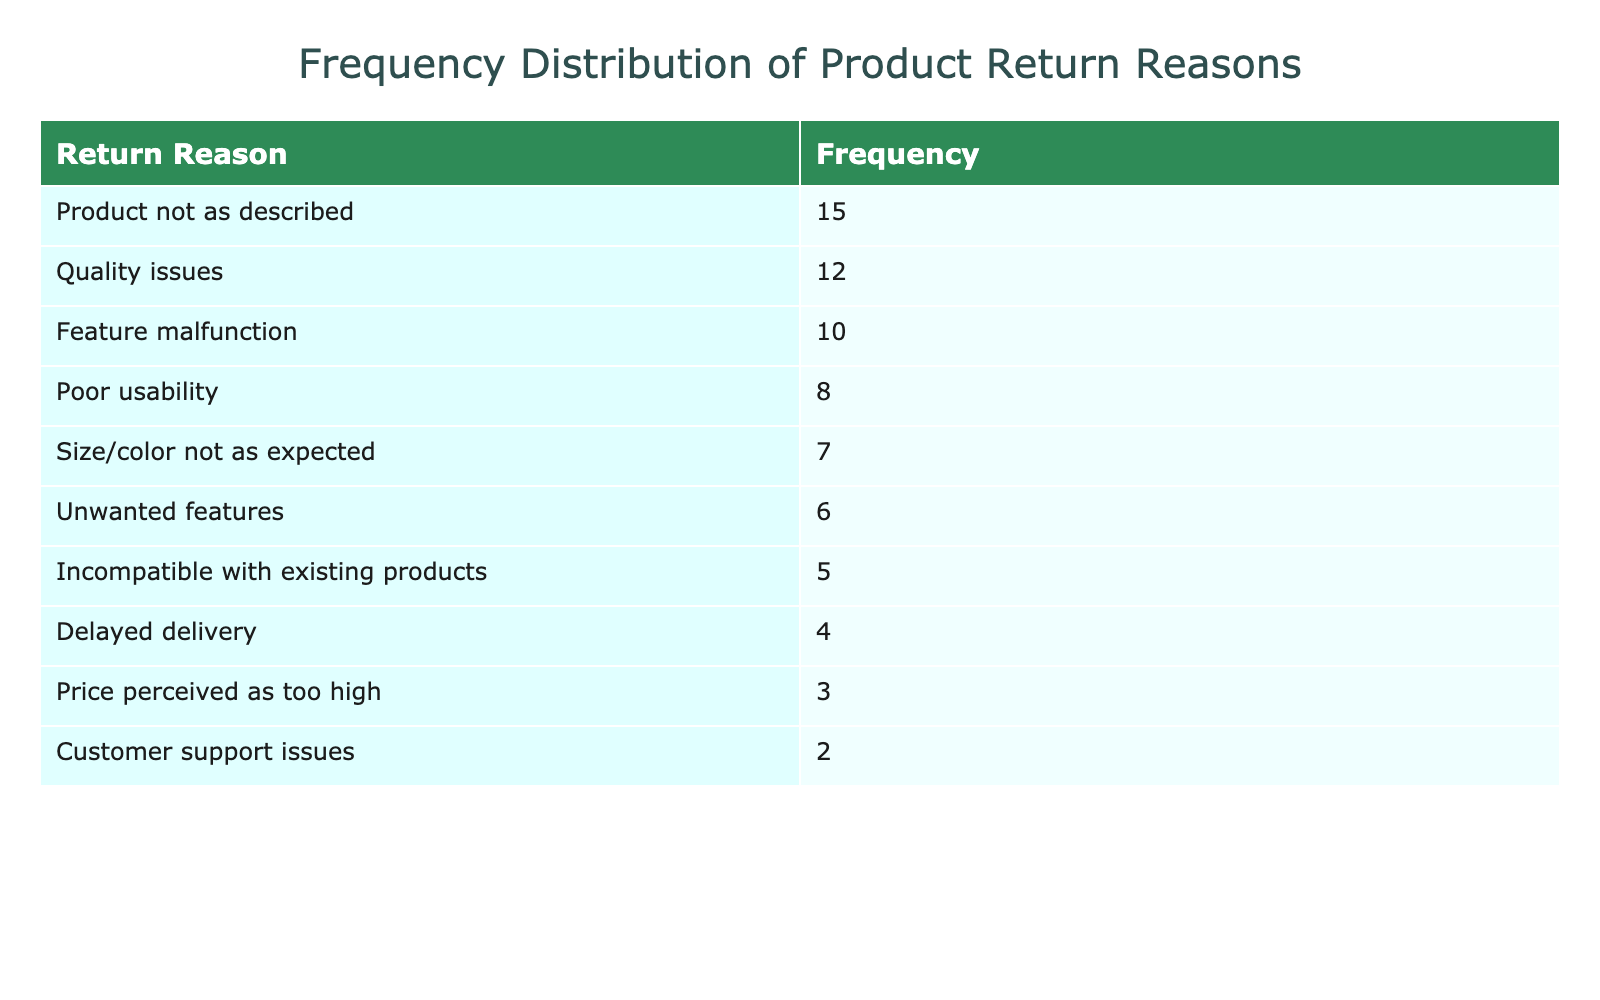What is the frequency of returns due to "Quality issues"? The table provides a direct value for the frequency of returns related to "Quality issues," which is given as 12.
Answer: 12 What return reason has the highest frequency? By looking at the sorted list in the table, the return reason with the highest frequency is "Product not as described," with a frequency of 15.
Answer: "Product not as described" Is the frequency of "Delayed delivery" higher than that of "Customer support issues"? The table shows that "Delayed delivery" has a frequency of 4, while "Customer support issues" has a frequency of 2. Since 4 is greater than 2, the frequency of "Delayed delivery" is indeed higher.
Answer: Yes What is the sum of the frequencies for the reasons "Poor usability," "Size/color not as expected," and "Unwanted features"? The frequencies for these reasons are 8, 7, and 6 respectively. Summing them gives 8 + 7 + 6 = 21.
Answer: 21 Is "Feature malfunction" the second most common return reason? The table lists "Feature malfunction" with a frequency of 10. Sorting the reasons, we find that "Product not as described" (15) is the most common and "Quality issues" (12) is the second most common. Since 10 is less than 12, it is not the second most common return reason.
Answer: No What is the average frequency of all return reasons listed? The total frequency sums to 15 + 10 + 8 + 5 + 4 + 12 + 6 + 7 + 3 + 2 = 72. There are 10 return reasons, so the average is 72 / 10 = 7.2.
Answer: 7.2 Which return reason has the lowest frequency? The lowest frequency in the table is for "Customer support issues," which has a frequency of 2. This is identifiable as it appears at the bottom of the sorted frequencies.
Answer: "Customer support issues" How many return reasons have a frequency greater than 5? Looking at the table, the return reasons with frequencies greater than 5 are "Product not as described" (15), "Quality issues" (12), "Feature malfunction" (10), "Poor usability" (8), and "Unwanted features" (6), totaling 5 reasons.
Answer: 5 What is the difference in frequency between "Feature malfunction" and "Size/color not as expected"? "Feature malfunction" has a frequency of 10, while "Size/color not as expected" has a frequency of 7. The difference is calculated as 10 - 7 = 3.
Answer: 3 